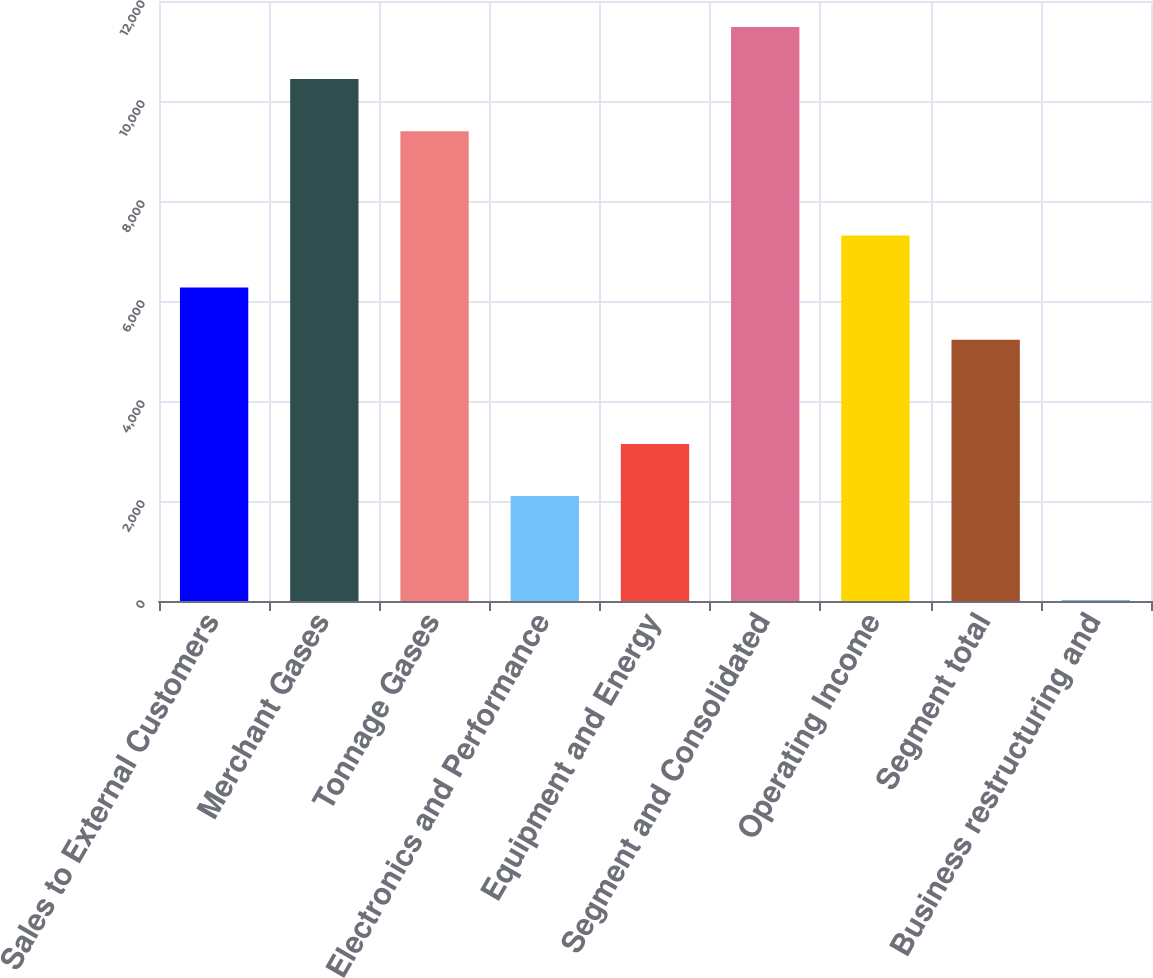<chart> <loc_0><loc_0><loc_500><loc_500><bar_chart><fcel>Sales to External Customers<fcel>Merchant Gases<fcel>Tonnage Gases<fcel>Electronics and Performance<fcel>Equipment and Energy<fcel>Segment and Consolidated<fcel>Operating Income<fcel>Segment total<fcel>Business restructuring and<nl><fcel>6268.48<fcel>10439<fcel>9396.37<fcel>2097.96<fcel>3140.59<fcel>11481.6<fcel>7311.11<fcel>5225.85<fcel>12.7<nl></chart> 